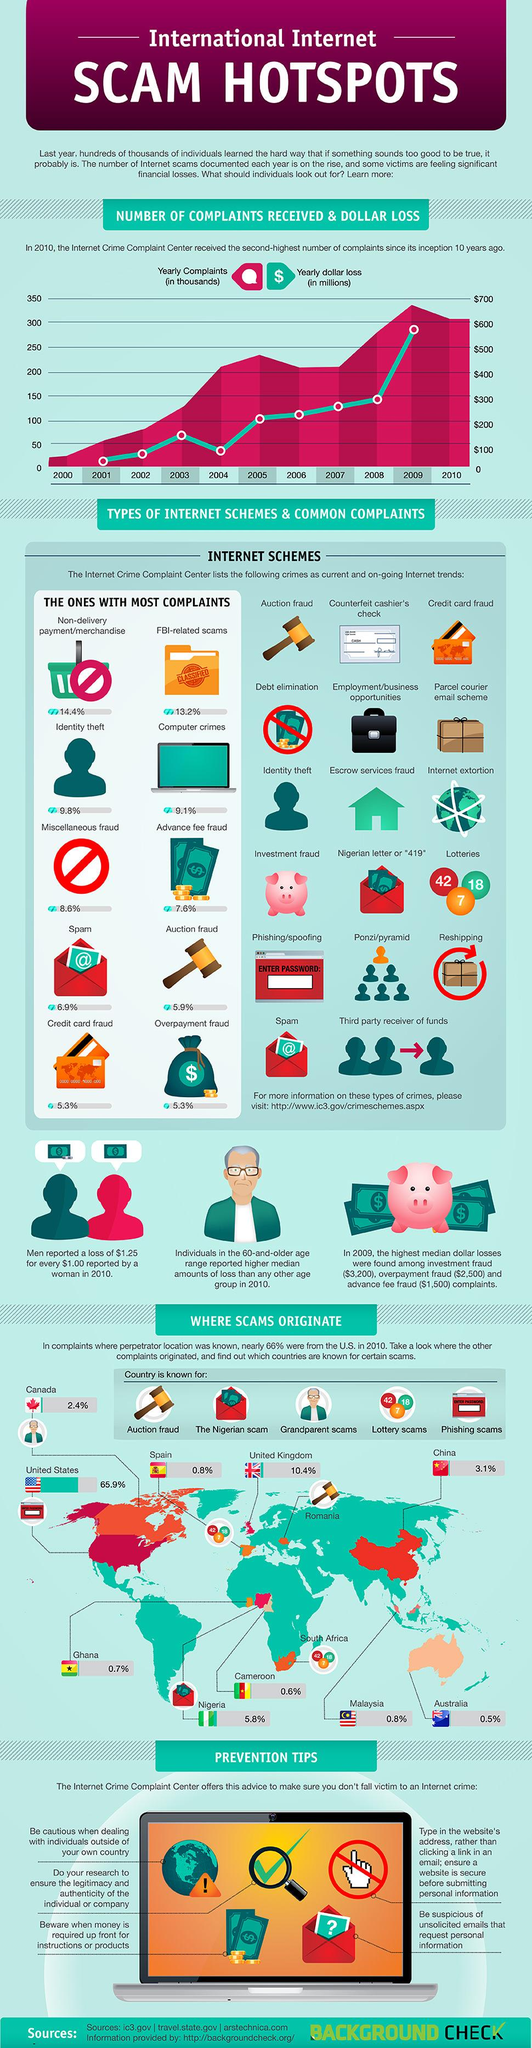Specify some key components in this picture. Credit card fraud and overpayment fraud have a complaint rate of 5.3%, according to data. In 2004, the yearly dollar loss experienced a significant decrease after a consistent increase since 2001. According to the information provided, the country with the lowest rate of internet crimes is Australia. According to recent data, FBI-related scams make up approximately 13.2% of all reported scams. There are 10 types of internet-based frauds that have the most complaints. 